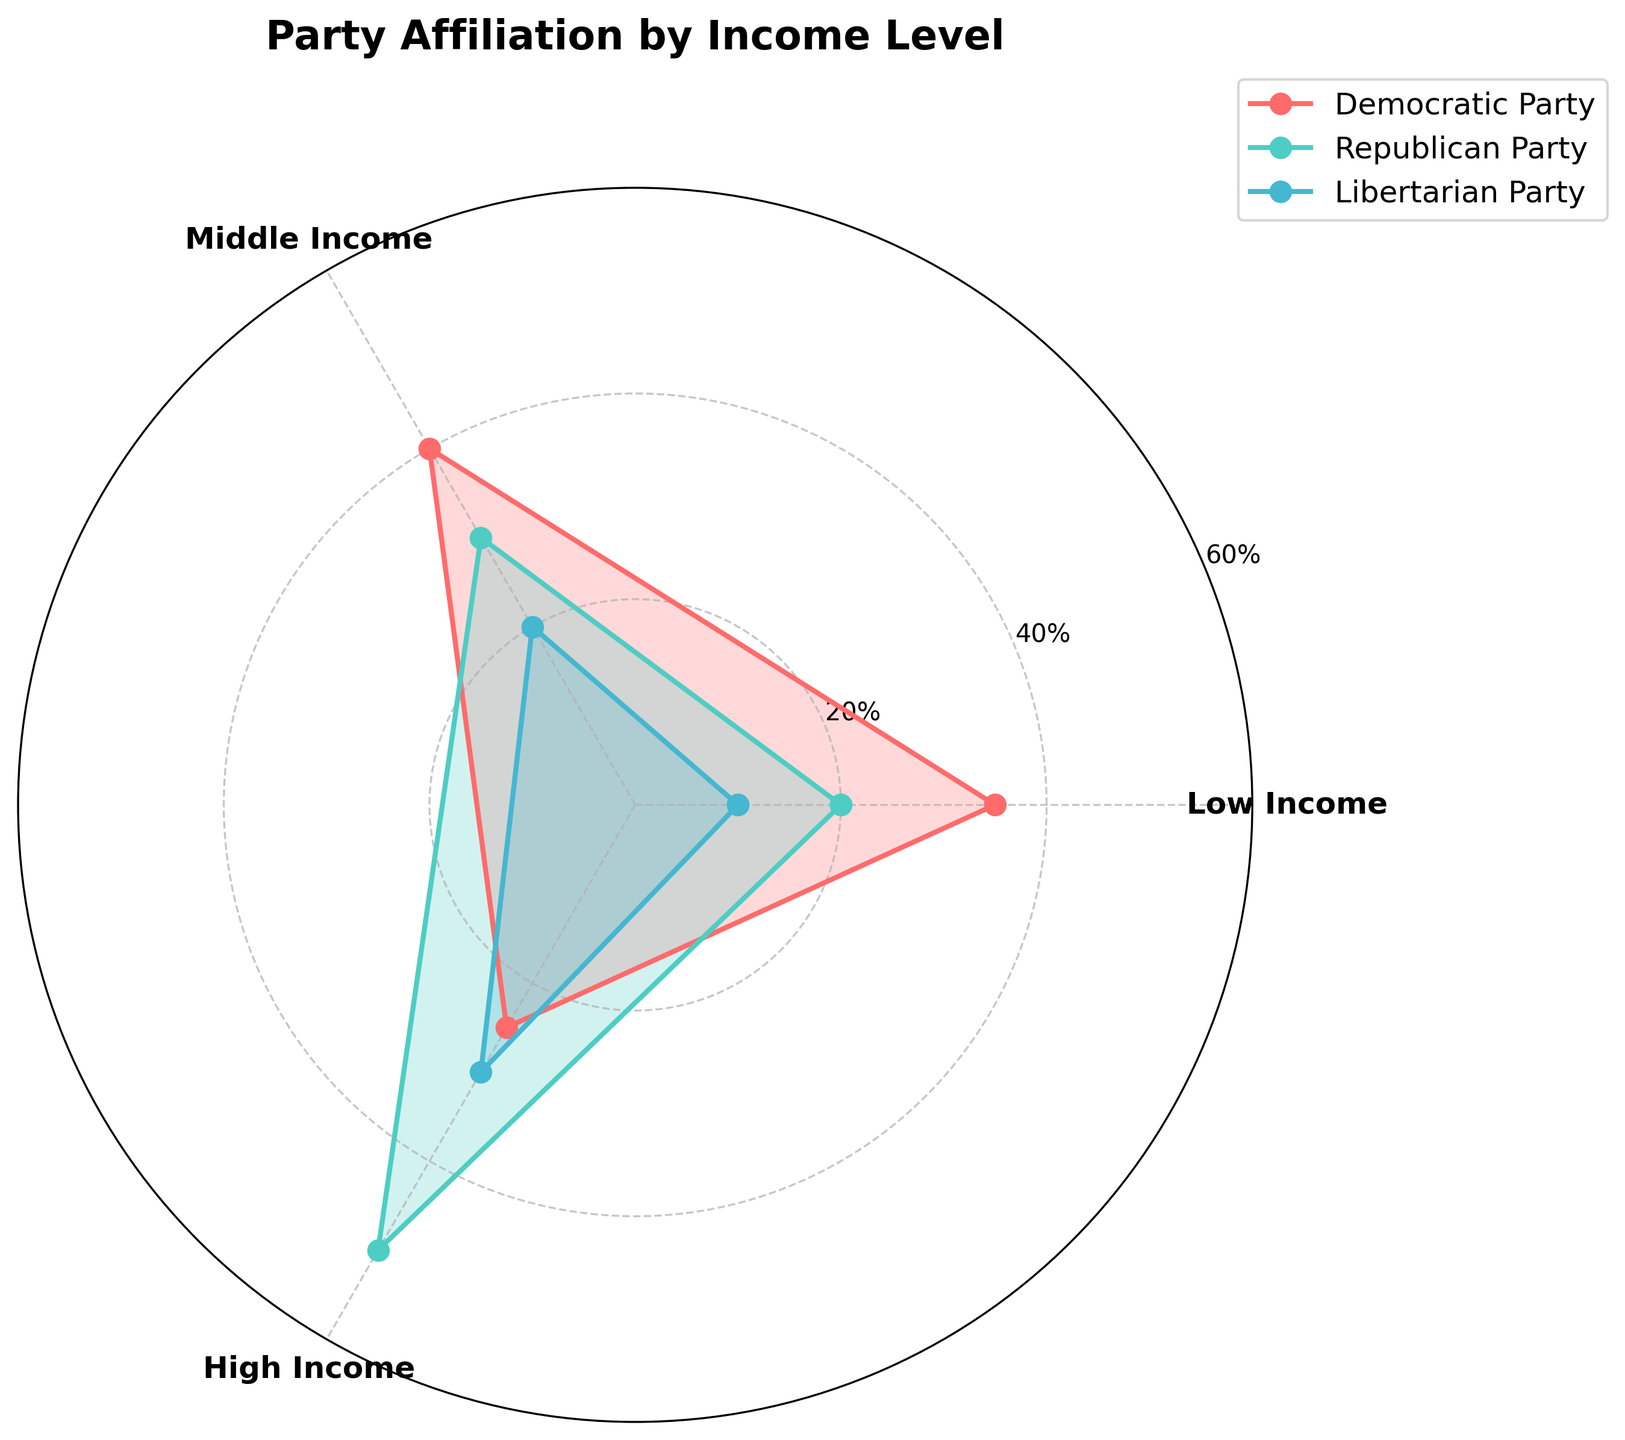What is the title of the chart? The title of the chart is written at the top of the figure, above the plot area
Answer: Party Affiliation by Income Level What are the three income levels shown in the rose chart? The income levels are represented as labels on the chart, set around the polar plot
Answer: Low Income, Middle Income, High Income Which party has the highest percentage within the High Income group? By looking at the plot, we can see which line reaches the highest value at the 'High Income' label
Answer: Republican Party What percentage of Low Income individuals affiliate with the Libertarian Party? The value can be found where the line for the Libertarian Party intersects with the Low Income label
Answer: 10% Who has higher support among Middle Income individuals, the Democratic Party or the Republican Party? Comparing the lines at the Middle Income label; the line representing the Democratic Party is higher than the one for the Republican Party
Answer: Democratic Party What is the combined percentage of Low Income individuals who affiliate with the Democratic and Republican parties? Add the percentages of the Democratic Party and Republican Party at the Low Income level: 35% (Democratic) + 20% (Republican)
Answer: 55% What is the difference in support for the Republican Party between the Middle Income and High Income groups? Subtract the percentage of Middle Income for the Republican Party from the High Income percentage: 50% (High Income) - 30% (Middle Income)
Answer: 20% Which party shows the most consistent level of support across all income levels? By observing how much each party's line varies around the circle, the party with the smallest variation is the most consistent. The Democratic Party's percentages (35%, 40%, 25%) vary the least
Answer: Democratic Party Which party's support increases with higher income levels? By looking at whether the percentages increase as you move from Low to High Income labels; the Republican Party (20%, 30%, 50%) shows an increasing trend
Answer: Republican Party Which party has the least representation among Low Income individuals? By checking which party's line has the lowest value at the Low Income label
Answer: Libertarian Party 